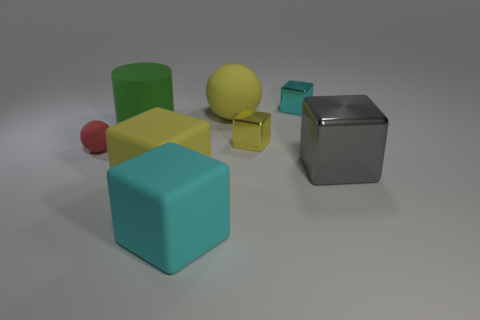I see various shapes; can you identify them? Of course! In the image, you can observe cubes, cylinders, and spheres. Specifically, there are three cubes, two cylinders, and one sphere. 